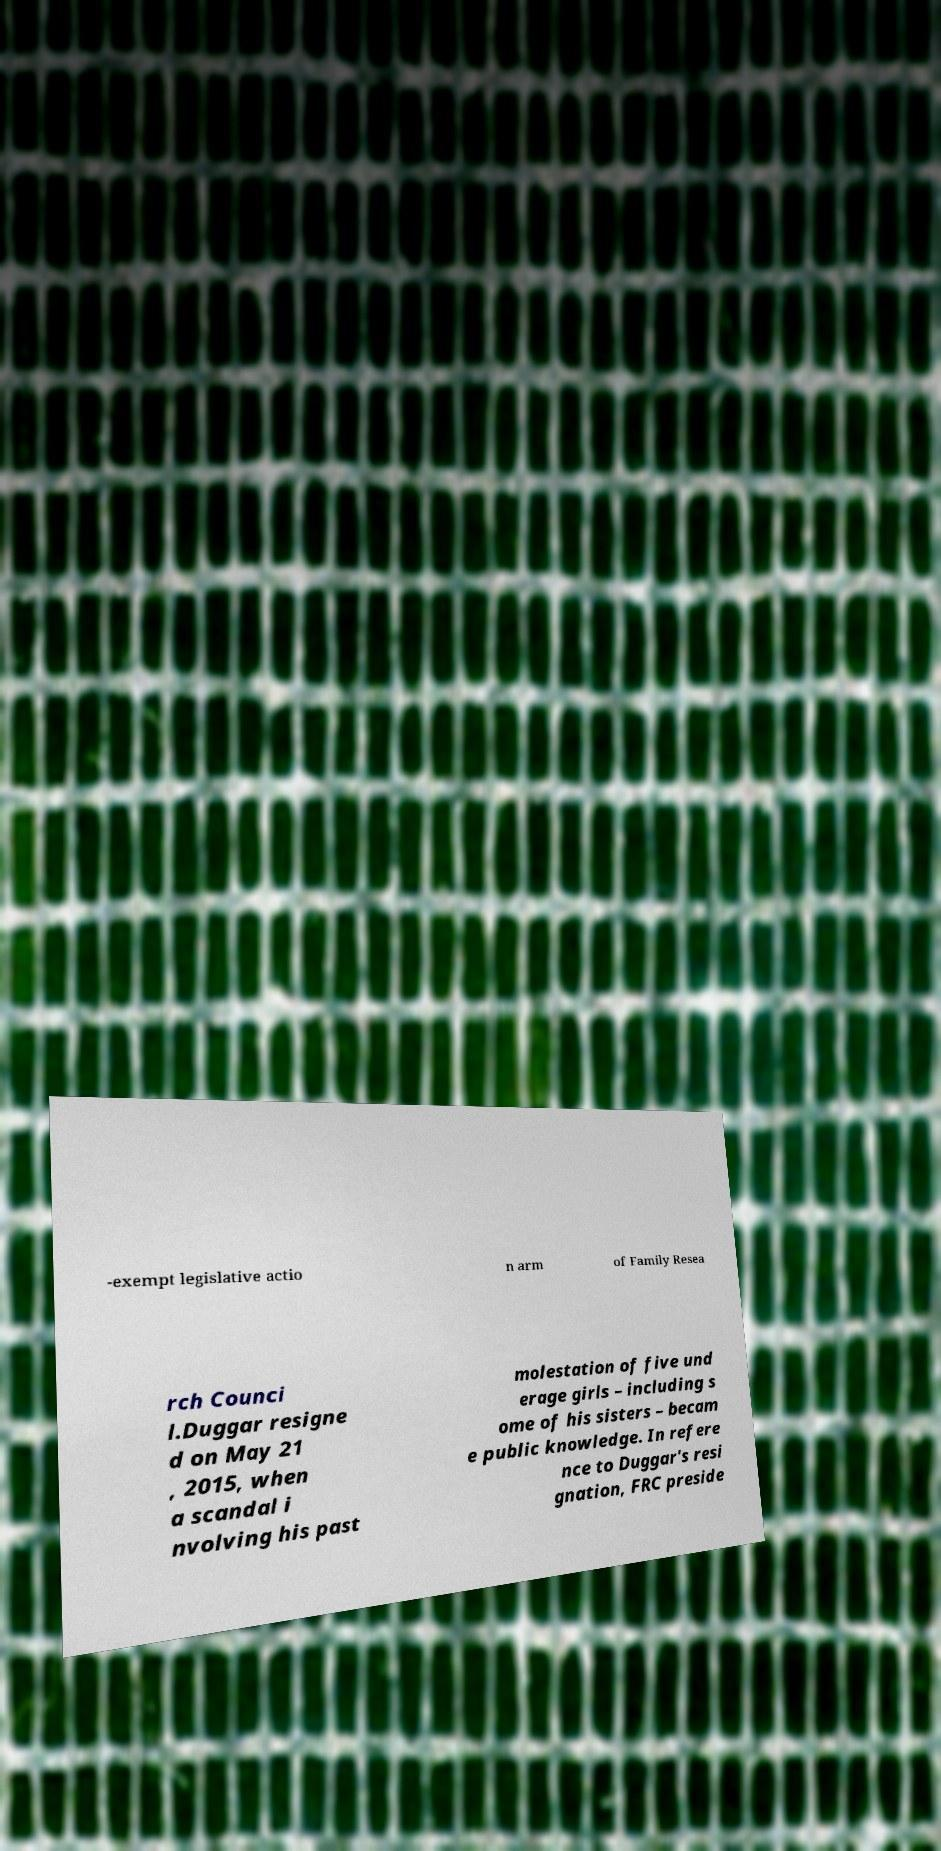Can you accurately transcribe the text from the provided image for me? -exempt legislative actio n arm of Family Resea rch Counci l.Duggar resigne d on May 21 , 2015, when a scandal i nvolving his past molestation of five und erage girls – including s ome of his sisters – becam e public knowledge. In refere nce to Duggar's resi gnation, FRC preside 